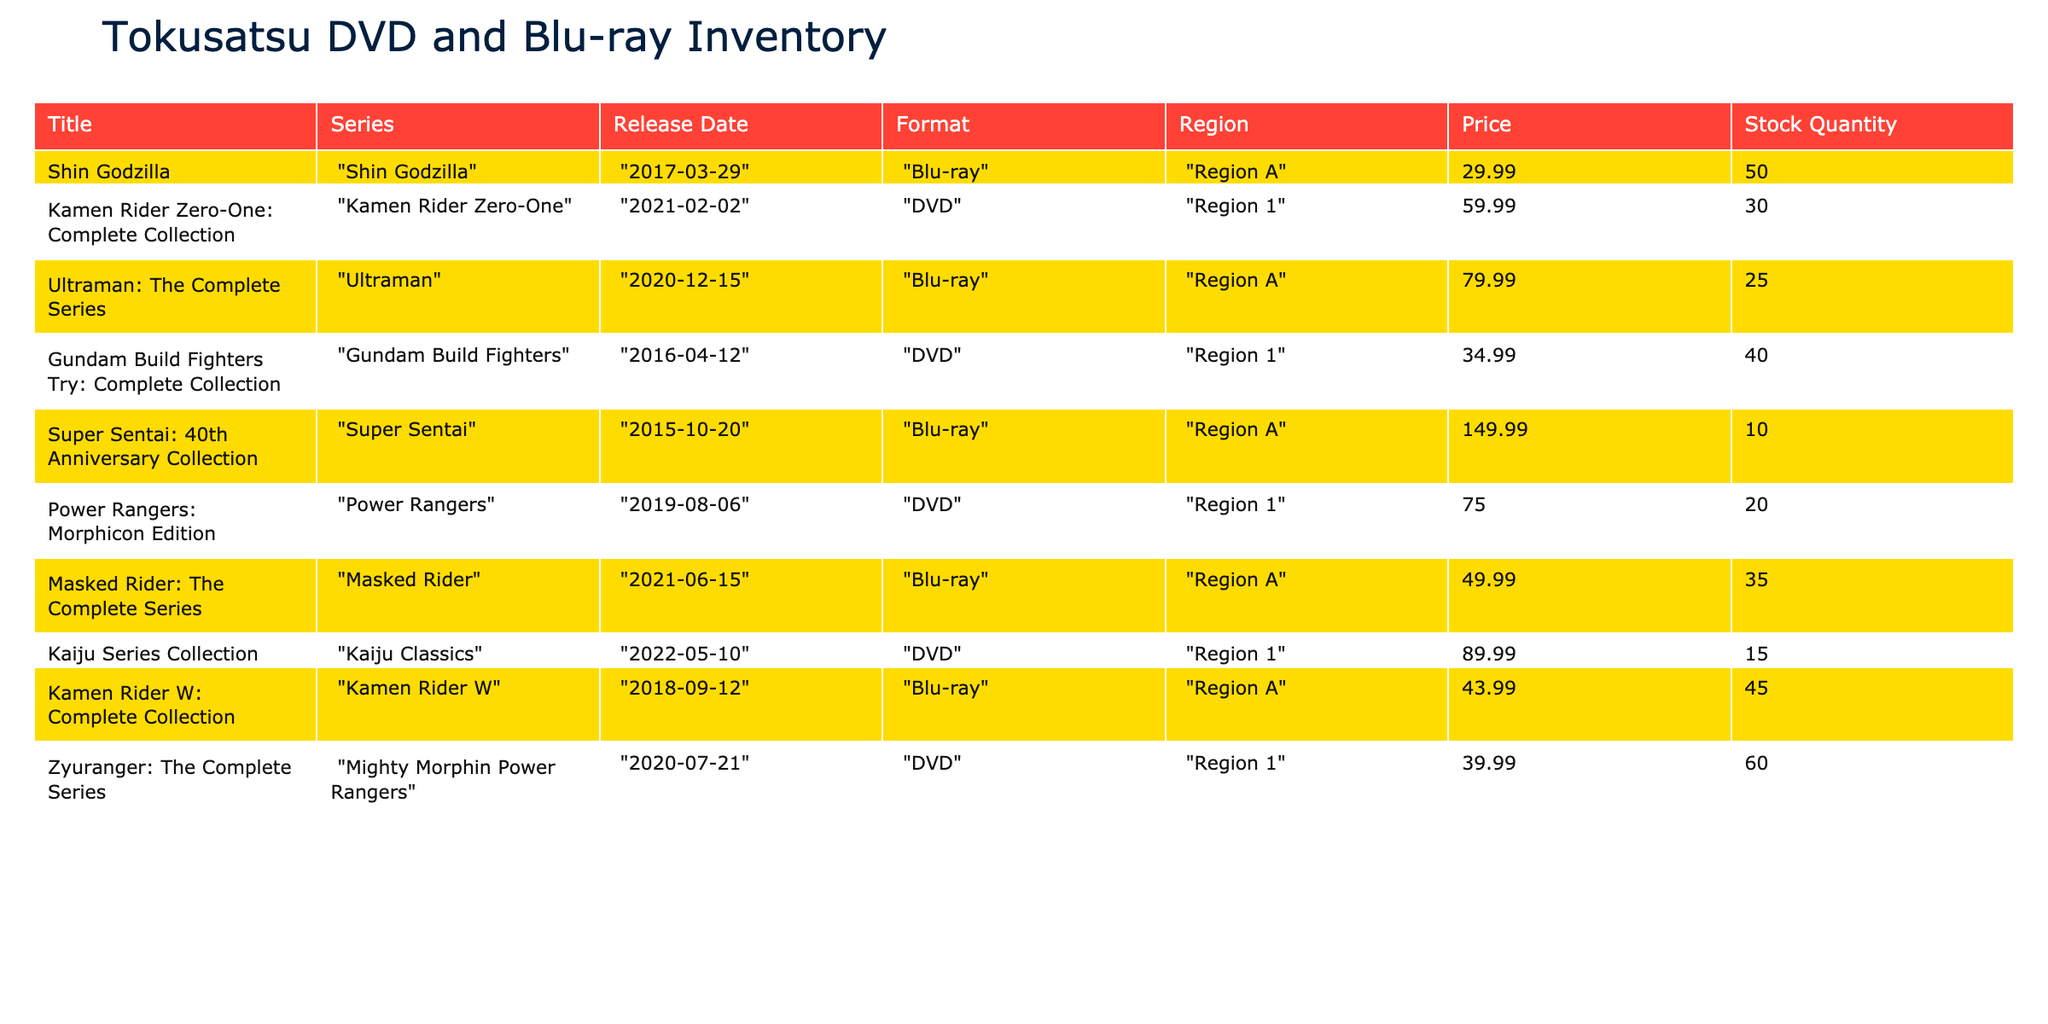What is the release date of "Ultraman: The Complete Series"? The table shows "Ultraman: The Complete Series" has a release date of "2020-12-15".
Answer: 2020-12-15 Which format has the largest stock quantity? When reviewing the stock quantity across all formats, DVD (specifically "Zyuranger: The Complete Series") has the largest stock at 60 units.
Answer: DVD What is the total stock quantity for all items in the inventory? To find the total stock quantity, I add all stock values together: 50 + 30 + 25 + 40 + 10 + 20 + 35 + 15 + 45 + 60 =  430.
Answer: 430 Is "Power Rangers: Morphicon Edition" available in Blu-ray format? The table shows "Power Rangers: Morphicon Edition" is listed under the DVD format, so it is not available in Blu-ray format.
Answer: No What is the price difference between the most expensive and the least expensive items? The most expensive item is "Super Sentai: 40th Anniversary Collection" at 149.99, and the least expensive is "Kamen Rider W: Complete Collection" at 43.99. The price difference is 149.99 - 43.99 = 106.00.
Answer: 106.00 Which series has a higher average price: DVD format or Blu-ray format? To find the average price of DVDs: (59.99 + 34.99 + 75.00 + 89.99 + 39.99) / 5 = 59.992. For Blu-ray: (29.99 + 79.99 + 49.99 + 43.99) / 4 = 50.245. The average price of DVDs (59.992) is higher than that of Blu-rays (50.245).
Answer: DVD How many titles are listed in Region A compared to Region 1? In the Region A category, there are 4 titles: "Shin Godzilla", "Ultraman: The Complete Series", "Masked Rider: The Complete Series", "Kamen Rider W: Complete Collection". In Region 1, there are 5 titles: "Kamen Rider Zero-One: Complete Collection", "Gundam Build Fighters Try: Complete Collection", "Power Rangers: Morphicon Edition", "Kaiju Series Collection", "Zyuranger: The Complete Series". There are more titles in Region 1.
Answer: Region 1 has more titles Does "Kamen Rider Zero-One: Complete Collection" have a stock quantity greater than 25? The stock quantity for "Kamen Rider Zero-One: Complete Collection" is 30, which is greater than 25.
Answer: Yes 